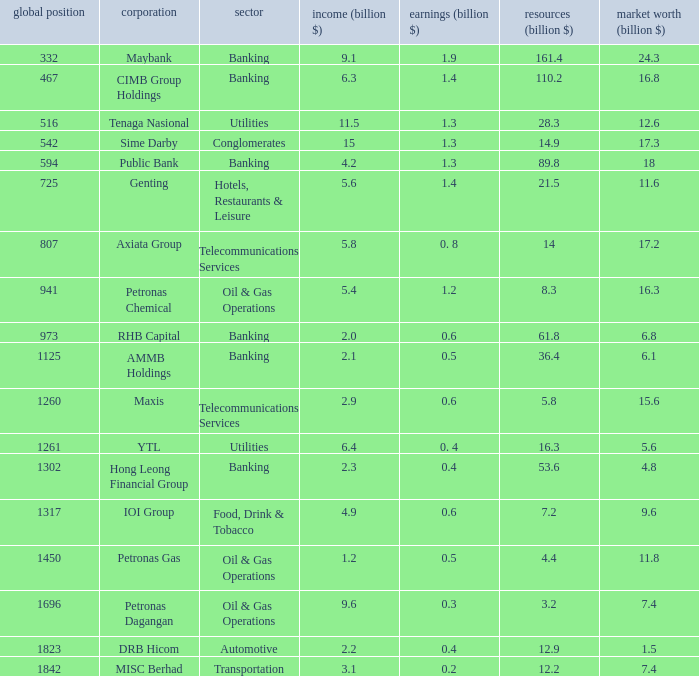Name the industry for revenue being 2.1 Banking. 